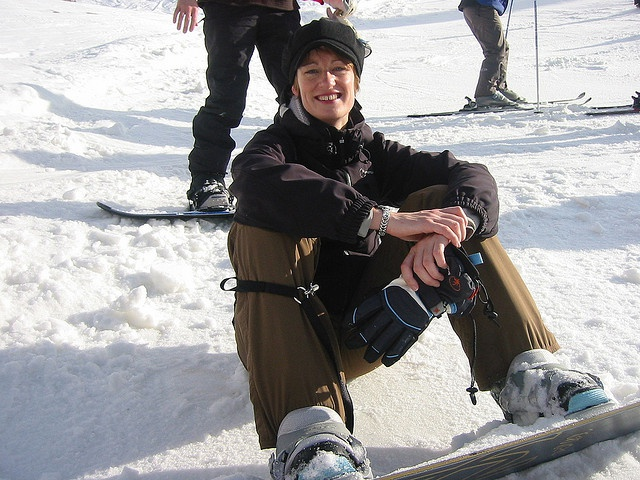Describe the objects in this image and their specific colors. I can see people in white, black, gray, and lightgray tones, people in white, black, and gray tones, snowboard in white, gray, black, lightgray, and darkgray tones, people in white, gray, black, and darkgray tones, and snowboard in white, lightgray, darkgray, and gray tones in this image. 